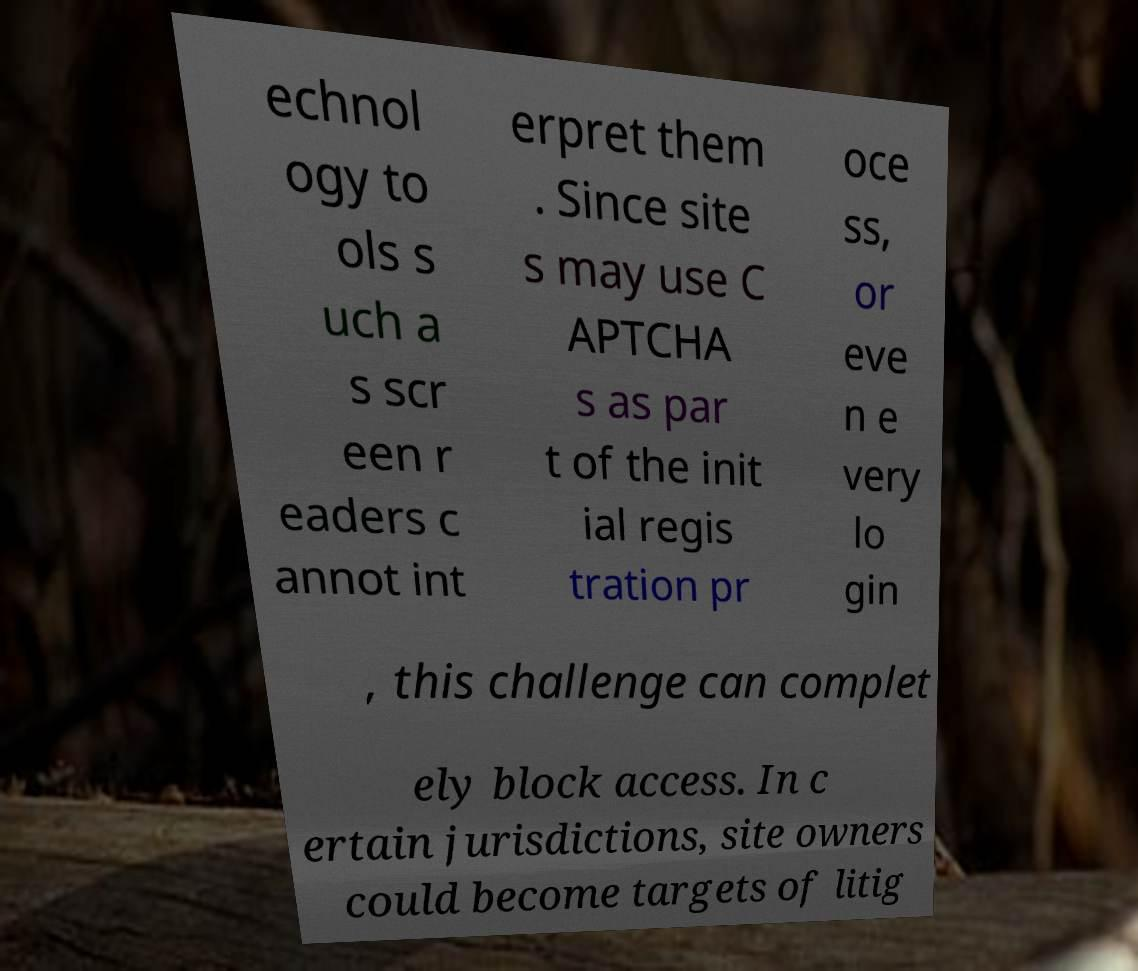Please read and relay the text visible in this image. What does it say? echnol ogy to ols s uch a s scr een r eaders c annot int erpret them . Since site s may use C APTCHA s as par t of the init ial regis tration pr oce ss, or eve n e very lo gin , this challenge can complet ely block access. In c ertain jurisdictions, site owners could become targets of litig 